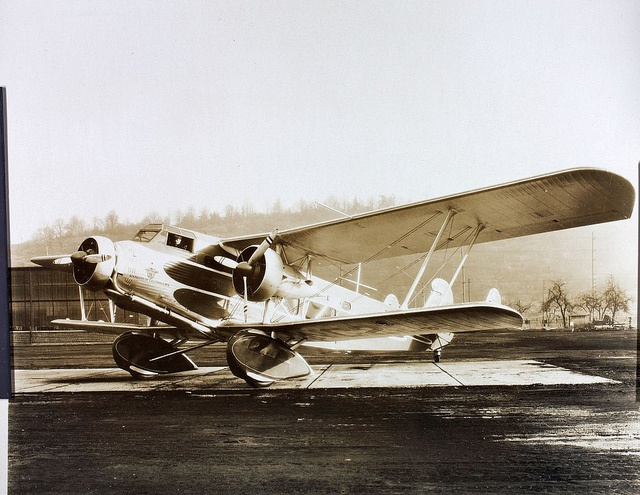Describe the objects in this image and their specific colors. I can see airplane in lightgray, black, tan, and gray tones and people in lightgray, black, gray, and maroon tones in this image. 